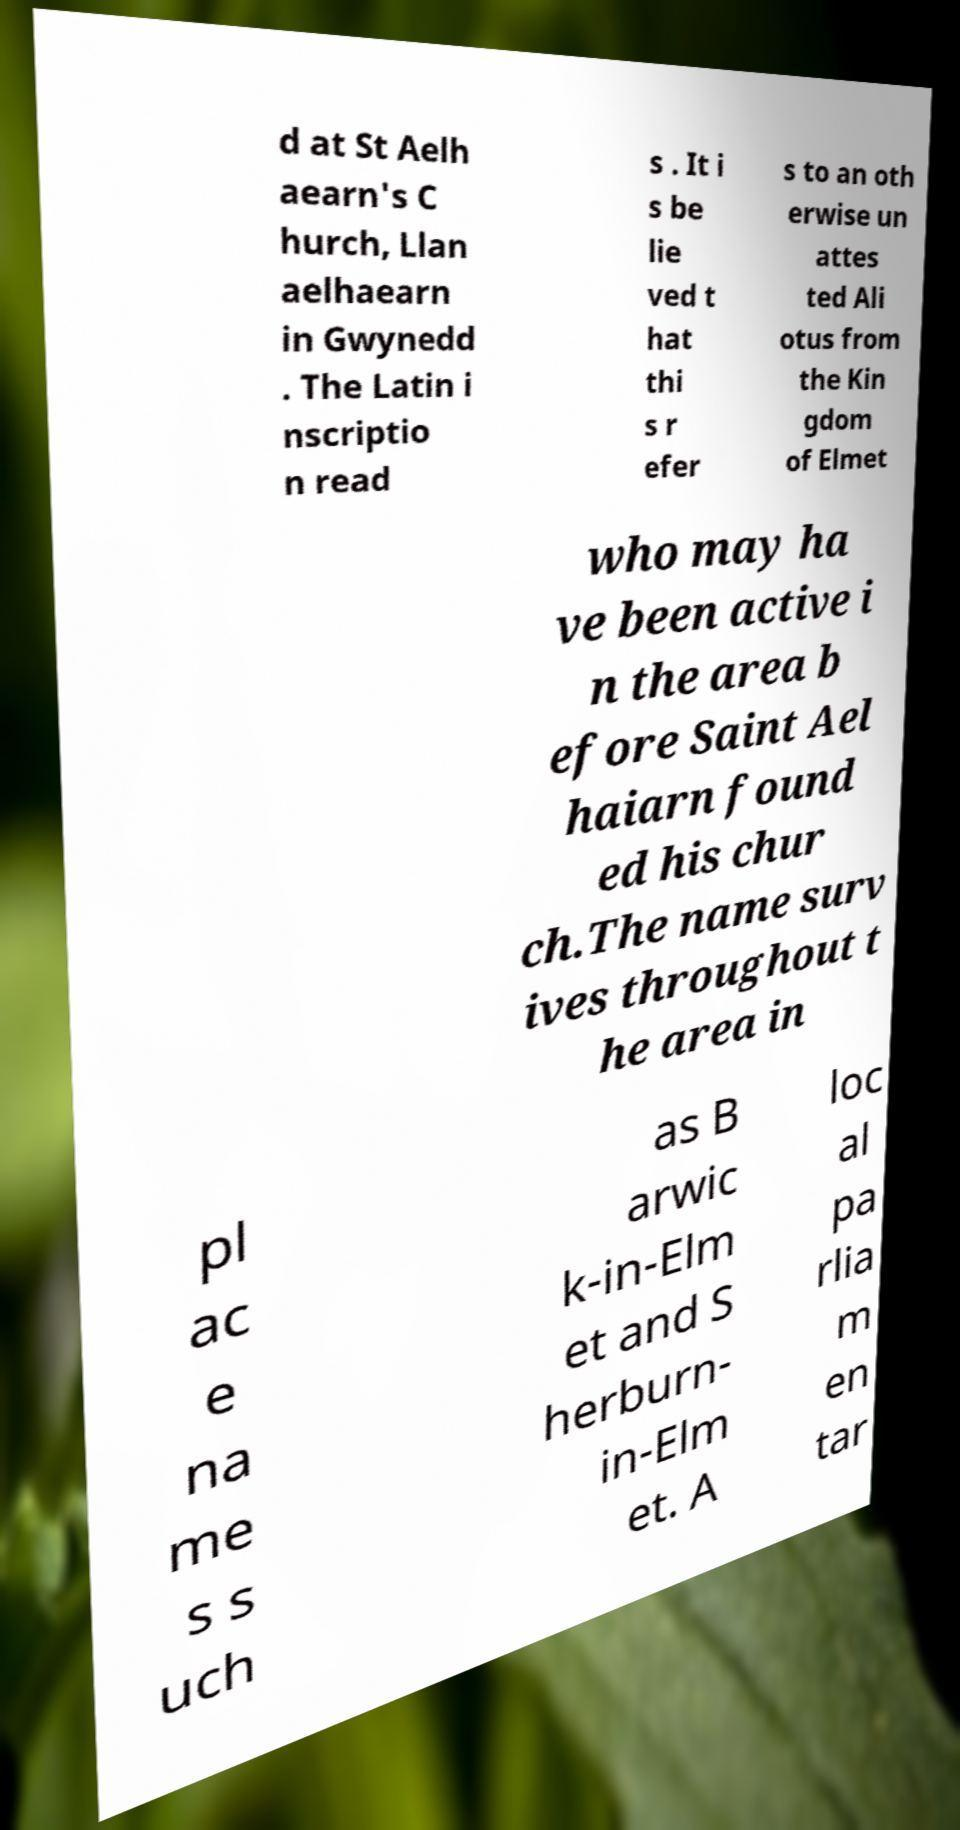There's text embedded in this image that I need extracted. Can you transcribe it verbatim? d at St Aelh aearn's C hurch, Llan aelhaearn in Gwynedd . The Latin i nscriptio n read s . It i s be lie ved t hat thi s r efer s to an oth erwise un attes ted Ali otus from the Kin gdom of Elmet who may ha ve been active i n the area b efore Saint Ael haiarn found ed his chur ch.The name surv ives throughout t he area in pl ac e na me s s uch as B arwic k-in-Elm et and S herburn- in-Elm et. A loc al pa rlia m en tar 